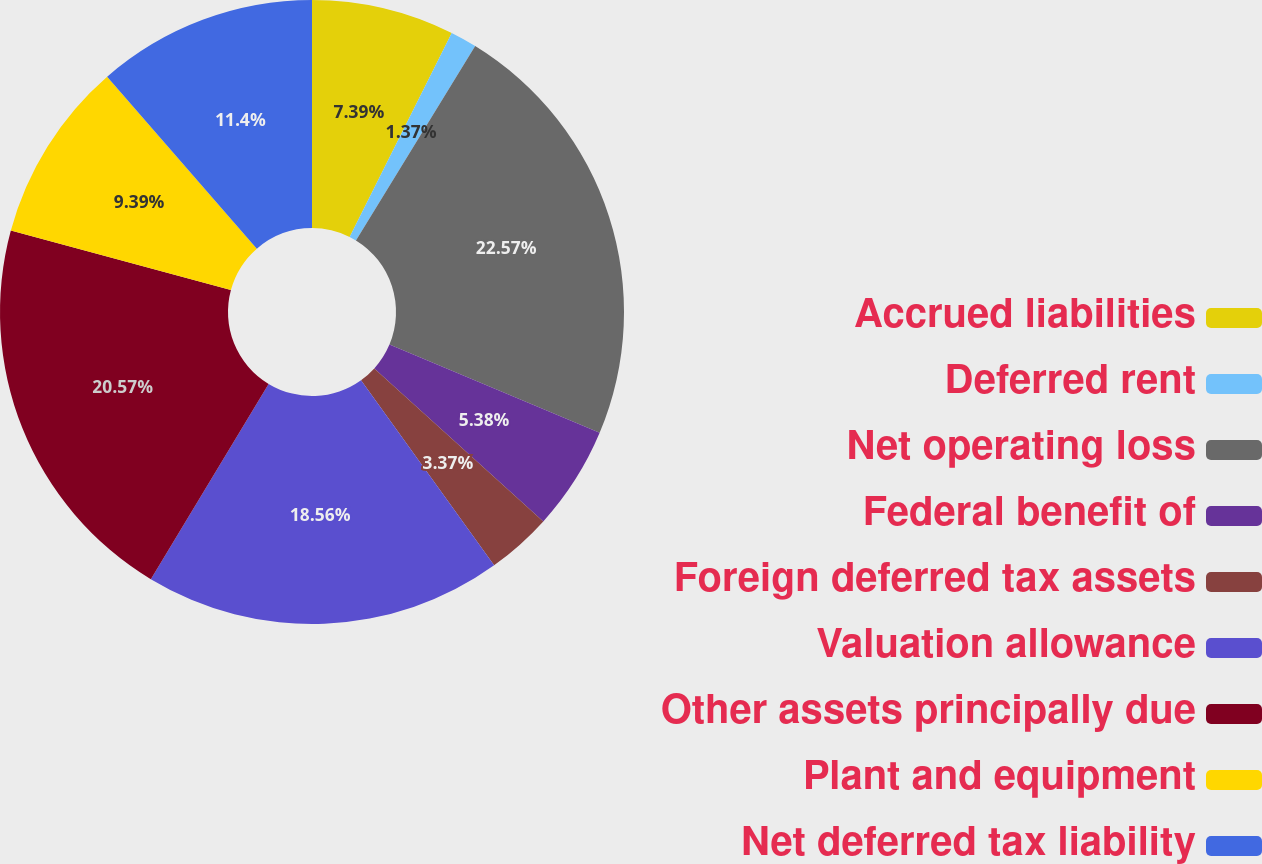Convert chart to OTSL. <chart><loc_0><loc_0><loc_500><loc_500><pie_chart><fcel>Accrued liabilities<fcel>Deferred rent<fcel>Net operating loss<fcel>Federal benefit of<fcel>Foreign deferred tax assets<fcel>Valuation allowance<fcel>Other assets principally due<fcel>Plant and equipment<fcel>Net deferred tax liability<nl><fcel>7.39%<fcel>1.37%<fcel>22.57%<fcel>5.38%<fcel>3.37%<fcel>18.56%<fcel>20.57%<fcel>9.39%<fcel>11.4%<nl></chart> 